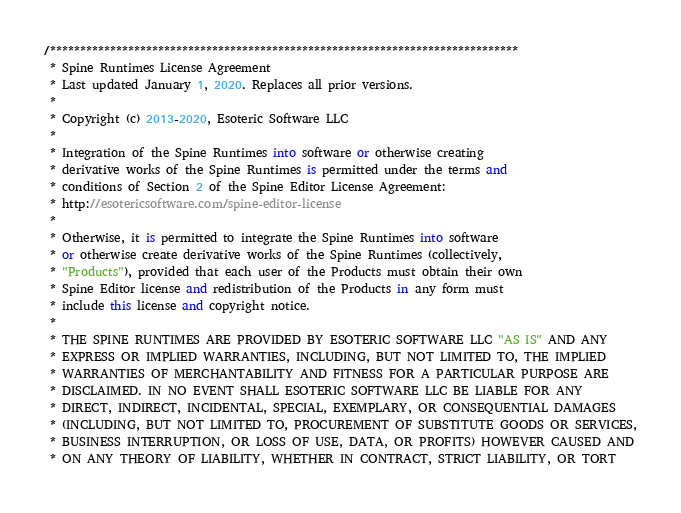Convert code to text. <code><loc_0><loc_0><loc_500><loc_500><_C#_>/******************************************************************************
 * Spine Runtimes License Agreement
 * Last updated January 1, 2020. Replaces all prior versions.
 *
 * Copyright (c) 2013-2020, Esoteric Software LLC
 *
 * Integration of the Spine Runtimes into software or otherwise creating
 * derivative works of the Spine Runtimes is permitted under the terms and
 * conditions of Section 2 of the Spine Editor License Agreement:
 * http://esotericsoftware.com/spine-editor-license
 *
 * Otherwise, it is permitted to integrate the Spine Runtimes into software
 * or otherwise create derivative works of the Spine Runtimes (collectively,
 * "Products"), provided that each user of the Products must obtain their own
 * Spine Editor license and redistribution of the Products in any form must
 * include this license and copyright notice.
 *
 * THE SPINE RUNTIMES ARE PROVIDED BY ESOTERIC SOFTWARE LLC "AS IS" AND ANY
 * EXPRESS OR IMPLIED WARRANTIES, INCLUDING, BUT NOT LIMITED TO, THE IMPLIED
 * WARRANTIES OF MERCHANTABILITY AND FITNESS FOR A PARTICULAR PURPOSE ARE
 * DISCLAIMED. IN NO EVENT SHALL ESOTERIC SOFTWARE LLC BE LIABLE FOR ANY
 * DIRECT, INDIRECT, INCIDENTAL, SPECIAL, EXEMPLARY, OR CONSEQUENTIAL DAMAGES
 * (INCLUDING, BUT NOT LIMITED TO, PROCUREMENT OF SUBSTITUTE GOODS OR SERVICES,
 * BUSINESS INTERRUPTION, OR LOSS OF USE, DATA, OR PROFITS) HOWEVER CAUSED AND
 * ON ANY THEORY OF LIABILITY, WHETHER IN CONTRACT, STRICT LIABILITY, OR TORT</code> 